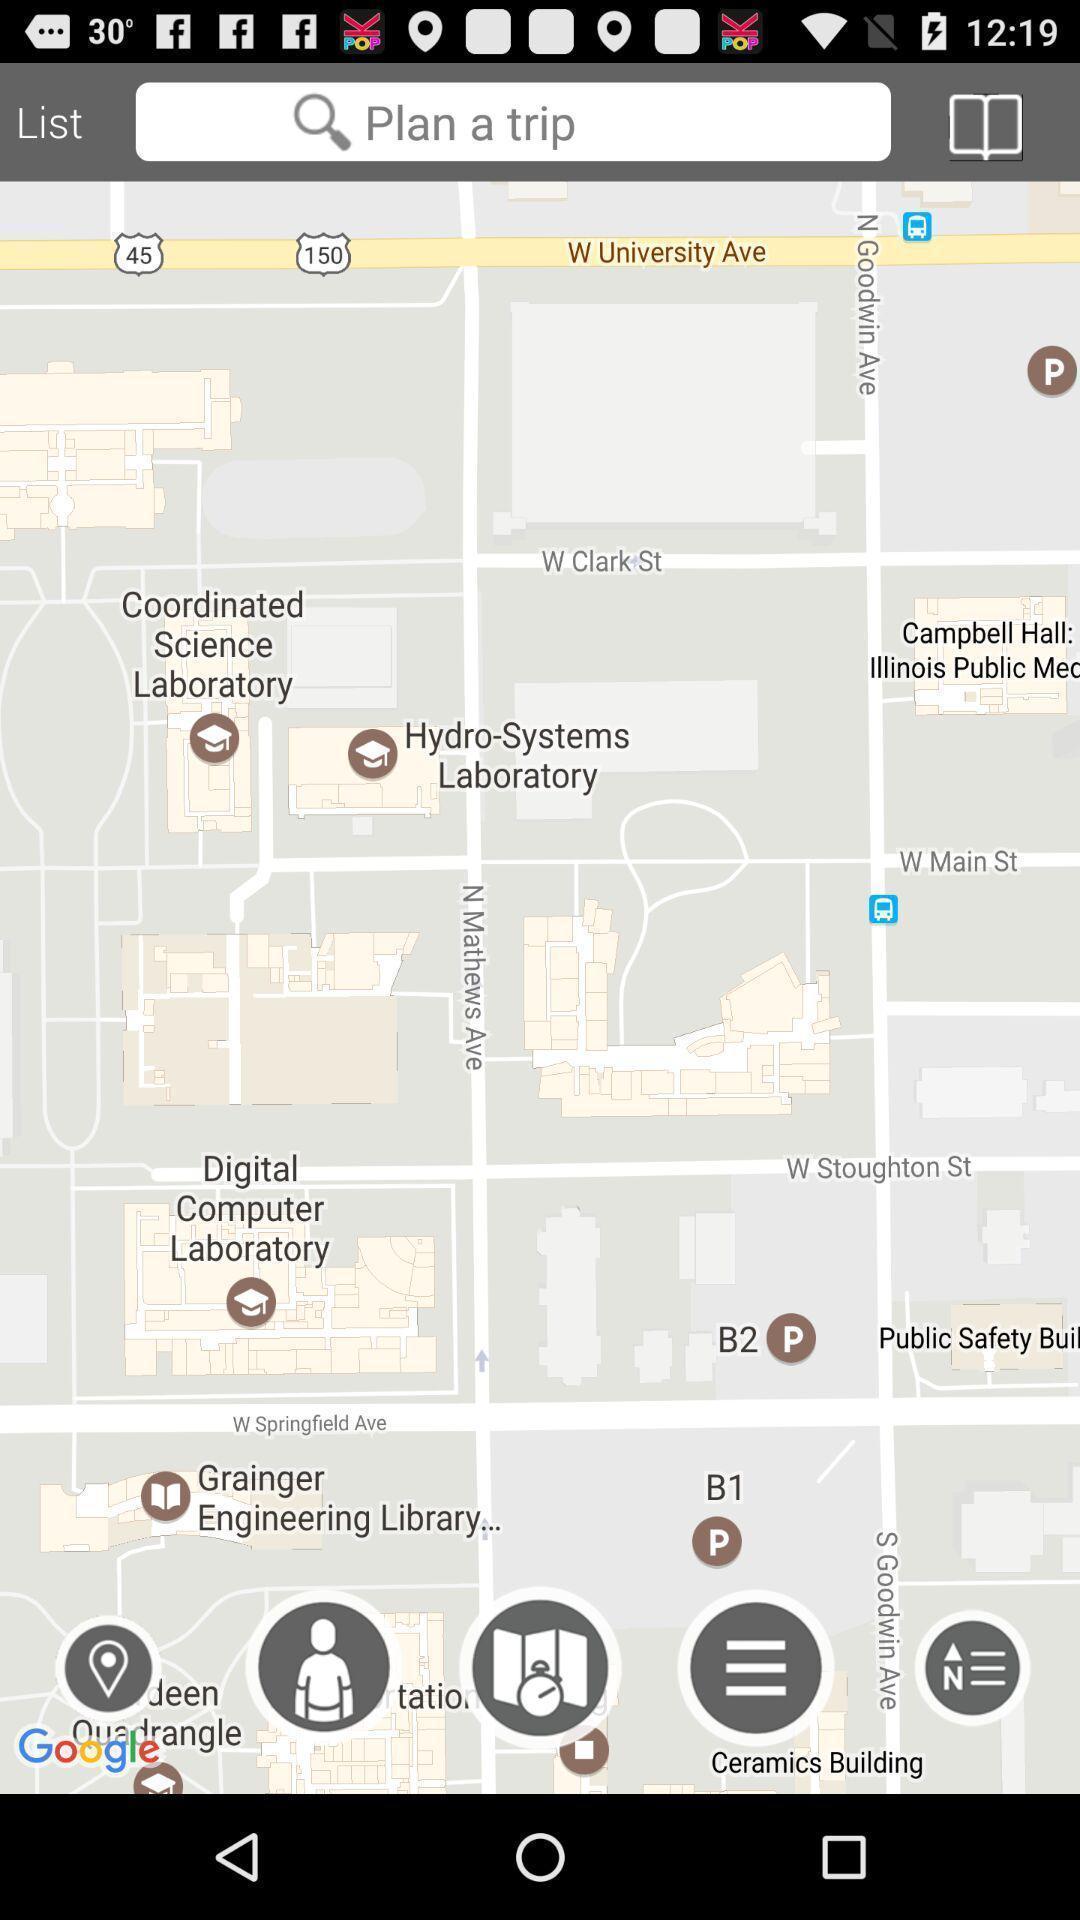What details can you identify in this image? Page shows to locate a map and to plan trip. 